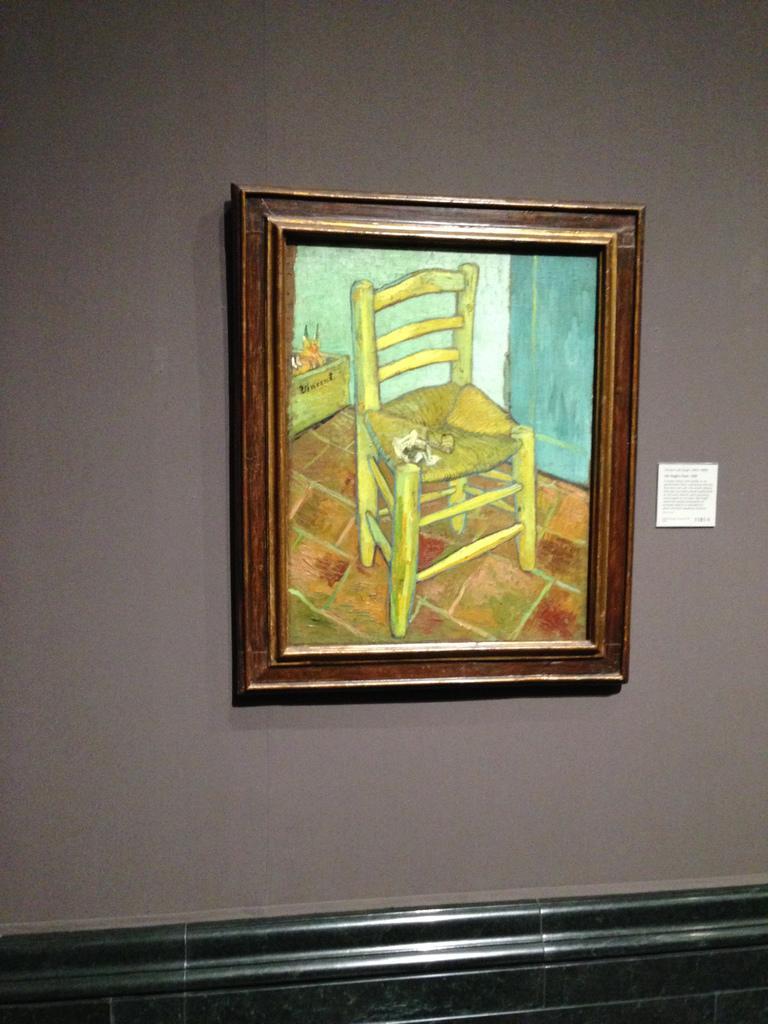Describe this image in one or two sentences. To the wall there is photo frame and the frame contains chair. 